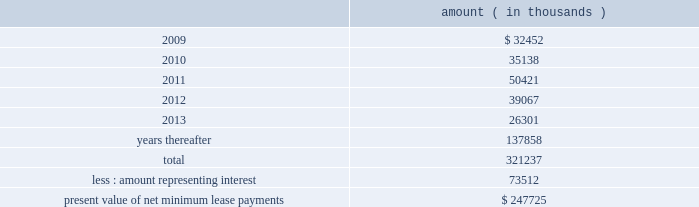Entergy corporation and subsidiaries notes to financial statements computed on a rolling 12 month basis .
As of december 31 , 2008 , entergy louisiana was in compliance with these provisions .
As of december 31 , 2008 , entergy louisiana had future minimum lease payments ( reflecting an overall implicit rate of 7.45% ( 7.45 % ) ) in connection with the waterford 3 sale and leaseback transactions , which are recorded as long-term debt , as follows : amount ( in thousands ) .
Grand gulf lease obligations in december 1988 , in two separate but substantially identical transactions , system energy sold and leased back undivided ownership interests in grand gulf for the aggregate sum of $ 500 million .
The interests represent approximately 11.5% ( 11.5 % ) of grand gulf .
The leases expire in 2015 .
Under certain circumstances , system entergy may repurchase the leased interests prior to the end of the term of the leases .
At the end of the lease terms , system energy has the option to repurchase the leased interests in grand gulf at fair market value or to renew the leases for either fair market value or , under certain conditions , a fixed rate .
In may 2004 , system energy caused the grand gulf lessors to refinance the outstanding bonds that they had issued to finance the purchase of their undivided interest in grand gulf .
The refinancing is at a lower interest rate , and system energy's lease payments have been reduced to reflect the lower interest costs .
System energy is required to report the sale-leaseback as a financing transaction in its financial statements .
For financial reporting purposes , system energy expenses the interest portion of the lease obligation and the plant depreciation .
However , operating revenues include the recovery of the lease payments because the transactions are accounted for as a sale and leaseback for ratemaking purposes .
Consistent with a recommendation contained in a ferc audit report , system energy initially recorded as a net regulatory asset the difference between the recovery of the lease payments and the amounts expensed for interest and depreciation and continues to record this difference as a regulatory asset or liability on an ongoing basis , resulting in a zero net balance for the regulatory asset at the end of the lease term .
The amount of this net regulatory asset was $ 19.2 million and $ 36.6 million as of december 31 , 2008 and 2007 , respectively. .
What portion of the future minimum lease payments for entergy louisiana will be used for interest payments? 
Computations: (73512 / 321237)
Answer: 0.22884. Entergy corporation and subsidiaries notes to financial statements computed on a rolling 12 month basis .
As of december 31 , 2008 , entergy louisiana was in compliance with these provisions .
As of december 31 , 2008 , entergy louisiana had future minimum lease payments ( reflecting an overall implicit rate of 7.45% ( 7.45 % ) ) in connection with the waterford 3 sale and leaseback transactions , which are recorded as long-term debt , as follows : amount ( in thousands ) .
Grand gulf lease obligations in december 1988 , in two separate but substantially identical transactions , system energy sold and leased back undivided ownership interests in grand gulf for the aggregate sum of $ 500 million .
The interests represent approximately 11.5% ( 11.5 % ) of grand gulf .
The leases expire in 2015 .
Under certain circumstances , system entergy may repurchase the leased interests prior to the end of the term of the leases .
At the end of the lease terms , system energy has the option to repurchase the leased interests in grand gulf at fair market value or to renew the leases for either fair market value or , under certain conditions , a fixed rate .
In may 2004 , system energy caused the grand gulf lessors to refinance the outstanding bonds that they had issued to finance the purchase of their undivided interest in grand gulf .
The refinancing is at a lower interest rate , and system energy's lease payments have been reduced to reflect the lower interest costs .
System energy is required to report the sale-leaseback as a financing transaction in its financial statements .
For financial reporting purposes , system energy expenses the interest portion of the lease obligation and the plant depreciation .
However , operating revenues include the recovery of the lease payments because the transactions are accounted for as a sale and leaseback for ratemaking purposes .
Consistent with a recommendation contained in a ferc audit report , system energy initially recorded as a net regulatory asset the difference between the recovery of the lease payments and the amounts expensed for interest and depreciation and continues to record this difference as a regulatory asset or liability on an ongoing basis , resulting in a zero net balance for the regulatory asset at the end of the lease term .
The amount of this net regulatory asset was $ 19.2 million and $ 36.6 million as of december 31 , 2008 and 2007 , respectively. .
Not including years 'thereafter' , what is the total lease payments ? ( in $ thousands )? 
Computations: (321237 - 137858)
Answer: 183379.0. 